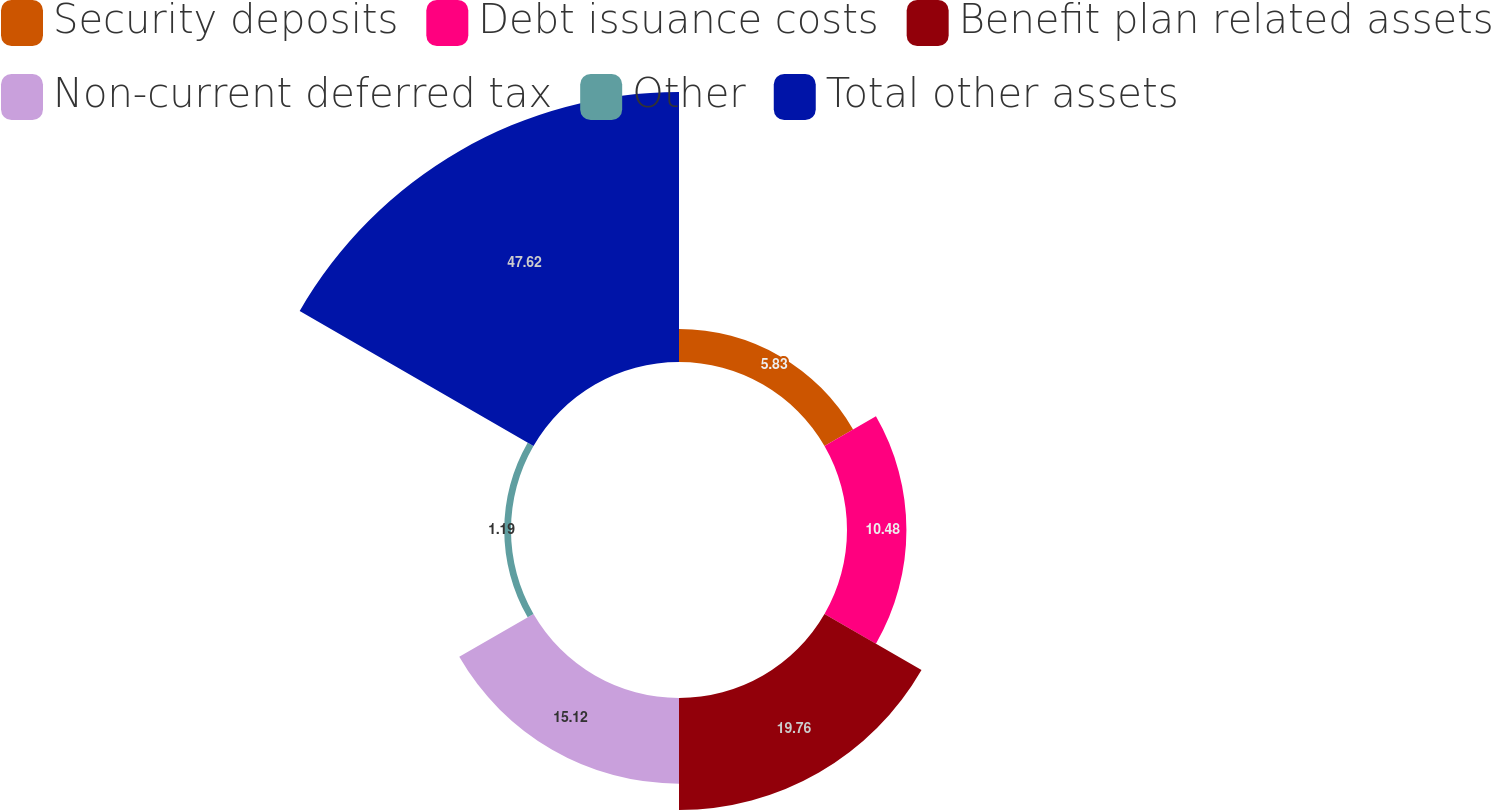<chart> <loc_0><loc_0><loc_500><loc_500><pie_chart><fcel>Security deposits<fcel>Debt issuance costs<fcel>Benefit plan related assets<fcel>Non-current deferred tax<fcel>Other<fcel>Total other assets<nl><fcel>5.83%<fcel>10.48%<fcel>19.76%<fcel>15.12%<fcel>1.19%<fcel>47.62%<nl></chart> 